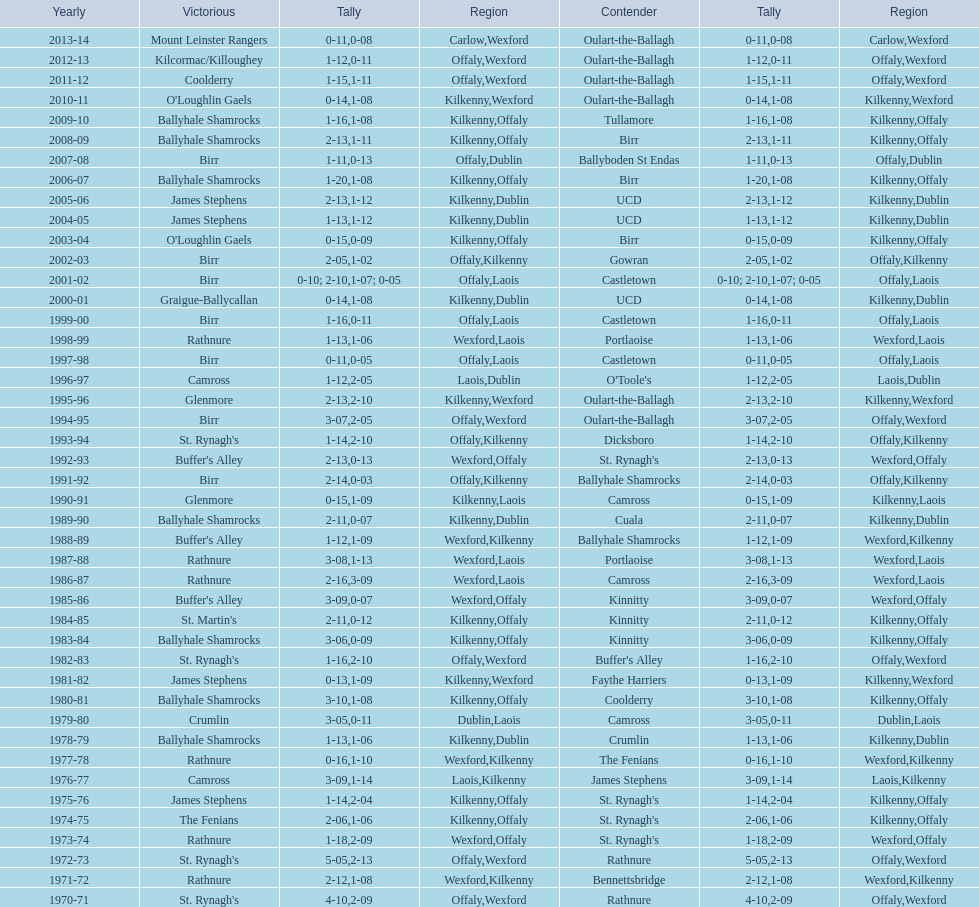James stephens won in 1976-76. who won three years before that? St. Rynagh's. Would you mind parsing the complete table? {'header': ['Yearly', 'Victorious', 'Tally', 'Region', 'Contender', 'Tally', 'Region'], 'rows': [['2013-14', 'Mount Leinster Rangers', '0-11', 'Carlow', 'Oulart-the-Ballagh', '0-08', 'Wexford'], ['2012-13', 'Kilcormac/Killoughey', '1-12', 'Offaly', 'Oulart-the-Ballagh', '0-11', 'Wexford'], ['2011-12', 'Coolderry', '1-15', 'Offaly', 'Oulart-the-Ballagh', '1-11', 'Wexford'], ['2010-11', "O'Loughlin Gaels", '0-14', 'Kilkenny', 'Oulart-the-Ballagh', '1-08', 'Wexford'], ['2009-10', 'Ballyhale Shamrocks', '1-16', 'Kilkenny', 'Tullamore', '1-08', 'Offaly'], ['2008-09', 'Ballyhale Shamrocks', '2-13', 'Kilkenny', 'Birr', '1-11', 'Offaly'], ['2007-08', 'Birr', '1-11', 'Offaly', 'Ballyboden St Endas', '0-13', 'Dublin'], ['2006-07', 'Ballyhale Shamrocks', '1-20', 'Kilkenny', 'Birr', '1-08', 'Offaly'], ['2005-06', 'James Stephens', '2-13', 'Kilkenny', 'UCD', '1-12', 'Dublin'], ['2004-05', 'James Stephens', '1-13', 'Kilkenny', 'UCD', '1-12', 'Dublin'], ['2003-04', "O'Loughlin Gaels", '0-15', 'Kilkenny', 'Birr', '0-09', 'Offaly'], ['2002-03', 'Birr', '2-05', 'Offaly', 'Gowran', '1-02', 'Kilkenny'], ['2001-02', 'Birr', '0-10; 2-10', 'Offaly', 'Castletown', '1-07; 0-05', 'Laois'], ['2000-01', 'Graigue-Ballycallan', '0-14', 'Kilkenny', 'UCD', '1-08', 'Dublin'], ['1999-00', 'Birr', '1-16', 'Offaly', 'Castletown', '0-11', 'Laois'], ['1998-99', 'Rathnure', '1-13', 'Wexford', 'Portlaoise', '1-06', 'Laois'], ['1997-98', 'Birr', '0-11', 'Offaly', 'Castletown', '0-05', 'Laois'], ['1996-97', 'Camross', '1-12', 'Laois', "O'Toole's", '2-05', 'Dublin'], ['1995-96', 'Glenmore', '2-13', 'Kilkenny', 'Oulart-the-Ballagh', '2-10', 'Wexford'], ['1994-95', 'Birr', '3-07', 'Offaly', 'Oulart-the-Ballagh', '2-05', 'Wexford'], ['1993-94', "St. Rynagh's", '1-14', 'Offaly', 'Dicksboro', '2-10', 'Kilkenny'], ['1992-93', "Buffer's Alley", '2-13', 'Wexford', "St. Rynagh's", '0-13', 'Offaly'], ['1991-92', 'Birr', '2-14', 'Offaly', 'Ballyhale Shamrocks', '0-03', 'Kilkenny'], ['1990-91', 'Glenmore', '0-15', 'Kilkenny', 'Camross', '1-09', 'Laois'], ['1989-90', 'Ballyhale Shamrocks', '2-11', 'Kilkenny', 'Cuala', '0-07', 'Dublin'], ['1988-89', "Buffer's Alley", '1-12', 'Wexford', 'Ballyhale Shamrocks', '1-09', 'Kilkenny'], ['1987-88', 'Rathnure', '3-08', 'Wexford', 'Portlaoise', '1-13', 'Laois'], ['1986-87', 'Rathnure', '2-16', 'Wexford', 'Camross', '3-09', 'Laois'], ['1985-86', "Buffer's Alley", '3-09', 'Wexford', 'Kinnitty', '0-07', 'Offaly'], ['1984-85', "St. Martin's", '2-11', 'Kilkenny', 'Kinnitty', '0-12', 'Offaly'], ['1983-84', 'Ballyhale Shamrocks', '3-06', 'Kilkenny', 'Kinnitty', '0-09', 'Offaly'], ['1982-83', "St. Rynagh's", '1-16', 'Offaly', "Buffer's Alley", '2-10', 'Wexford'], ['1981-82', 'James Stephens', '0-13', 'Kilkenny', 'Faythe Harriers', '1-09', 'Wexford'], ['1980-81', 'Ballyhale Shamrocks', '3-10', 'Kilkenny', 'Coolderry', '1-08', 'Offaly'], ['1979-80', 'Crumlin', '3-05', 'Dublin', 'Camross', '0-11', 'Laois'], ['1978-79', 'Ballyhale Shamrocks', '1-13', 'Kilkenny', 'Crumlin', '1-06', 'Dublin'], ['1977-78', 'Rathnure', '0-16', 'Wexford', 'The Fenians', '1-10', 'Kilkenny'], ['1976-77', 'Camross', '3-09', 'Laois', 'James Stephens', '1-14', 'Kilkenny'], ['1975-76', 'James Stephens', '1-14', 'Kilkenny', "St. Rynagh's", '2-04', 'Offaly'], ['1974-75', 'The Fenians', '2-06', 'Kilkenny', "St. Rynagh's", '1-06', 'Offaly'], ['1973-74', 'Rathnure', '1-18', 'Wexford', "St. Rynagh's", '2-09', 'Offaly'], ['1972-73', "St. Rynagh's", '5-05', 'Offaly', 'Rathnure', '2-13', 'Wexford'], ['1971-72', 'Rathnure', '2-12', 'Wexford', 'Bennettsbridge', '1-08', 'Kilkenny'], ['1970-71', "St. Rynagh's", '4-10', 'Offaly', 'Rathnure', '2-09', 'Wexford']]} 